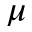<formula> <loc_0><loc_0><loc_500><loc_500>\mu</formula> 